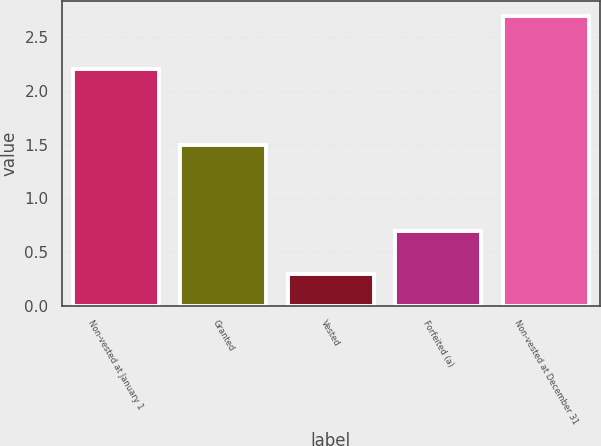Convert chart to OTSL. <chart><loc_0><loc_0><loc_500><loc_500><bar_chart><fcel>Non-vested at January 1<fcel>Granted<fcel>Vested<fcel>Forfeited (a)<fcel>Non-vested at December 31<nl><fcel>2.2<fcel>1.5<fcel>0.3<fcel>0.7<fcel>2.7<nl></chart> 